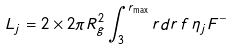<formula> <loc_0><loc_0><loc_500><loc_500>L _ { j } = 2 \times 2 \pi R _ { g } ^ { 2 } \int _ { 3 } ^ { r _ { \max } } r d r \, f \, \eta _ { j } F ^ { - }</formula> 